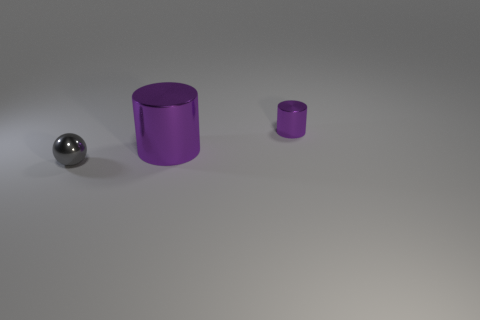There is a cylinder in front of the small shiny thing behind the tiny metallic thing that is on the left side of the big metallic cylinder; what size is it?
Give a very brief answer. Large. Does the ball in front of the large metal thing have the same material as the tiny object on the right side of the gray ball?
Make the answer very short. Yes. What number of other objects are there of the same color as the tiny shiny cylinder?
Your answer should be compact. 1. How many objects are either objects that are behind the gray thing or metallic objects that are on the right side of the gray metallic ball?
Offer a very short reply. 2. What size is the shiny object behind the metallic cylinder that is in front of the small purple thing?
Your answer should be very brief. Small. The gray metallic ball has what size?
Your answer should be very brief. Small. There is a cylinder that is to the left of the tiny shiny cylinder; does it have the same color as the small thing behind the gray metallic object?
Keep it short and to the point. Yes. Are any spheres visible?
Your response must be concise. Yes. Do the tiny gray ball in front of the big object and the small purple thing have the same material?
Your response must be concise. Yes. There is another object that is the same shape as the large purple shiny object; what material is it?
Your response must be concise. Metal. 